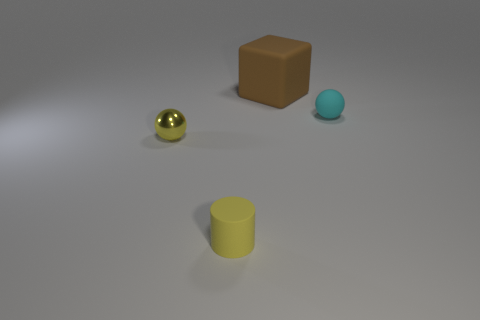Add 2 tiny gray metallic things. How many objects exist? 6 Subtract all cylinders. How many objects are left? 3 Subtract all small yellow metal things. Subtract all large purple metallic balls. How many objects are left? 3 Add 4 big brown objects. How many big brown objects are left? 5 Add 1 tiny brown shiny cubes. How many tiny brown shiny cubes exist? 1 Subtract 1 yellow cylinders. How many objects are left? 3 